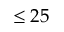<formula> <loc_0><loc_0><loc_500><loc_500>\leq 2 5</formula> 